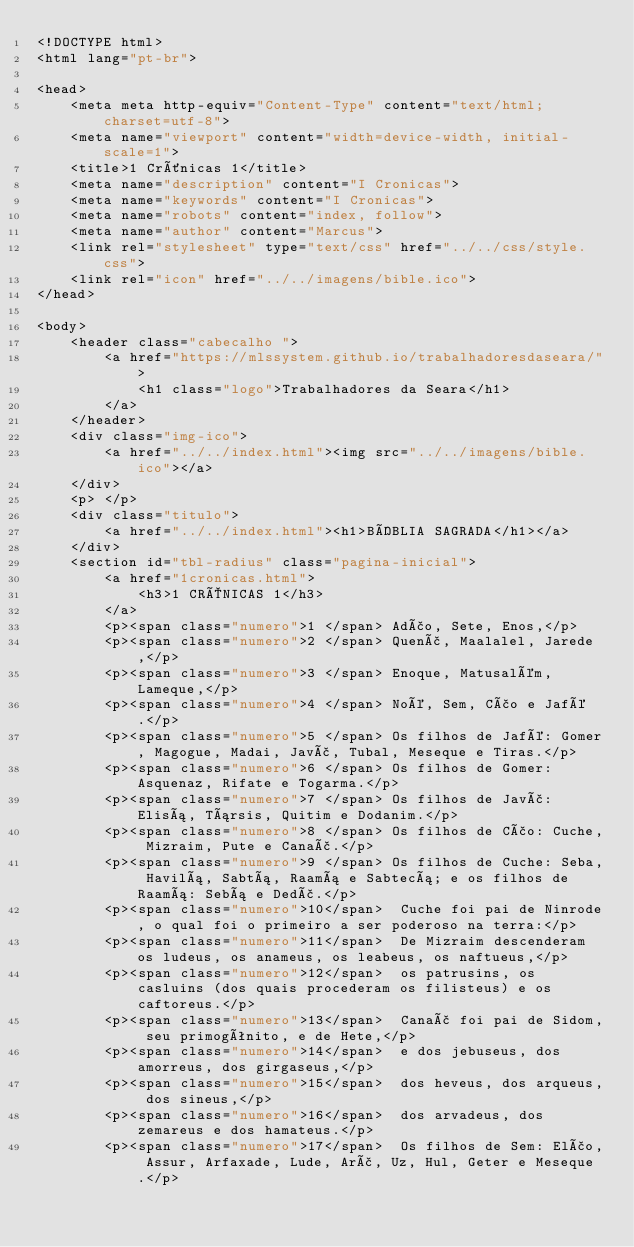Convert code to text. <code><loc_0><loc_0><loc_500><loc_500><_HTML_><!DOCTYPE html>
<html lang="pt-br">

<head>
    <meta meta http-equiv="Content-Type" content="text/html; charset=utf-8">
    <meta name="viewport" content="width=device-width, initial-scale=1">
    <title>1 Crônicas 1</title>
    <meta name="description" content="I Cronicas">
    <meta name="keywords" content="I Cronicas">
    <meta name="robots" content="index, follow">
    <meta name="author" content="Marcus">
    <link rel="stylesheet" type="text/css" href="../../css/style.css">
    <link rel="icon" href="../../imagens/bible.ico">
</head>

<body>
    <header class="cabecalho ">
        <a href="https://mlssystem.github.io/trabalhadoresdaseara/">
            <h1 class="logo">Trabalhadores da Seara</h1>
        </a>
    </header>
    <div class="img-ico">
        <a href="../../index.html"><img src="../../imagens/bible.ico"></a>
    </div>
    <p> </p> 
    <div class="titulo">
        <a href="../../index.html"><h1>BÍBLIA SAGRADA</h1></a>
    </div>
    <section id="tbl-radius" class="pagina-inicial">
        <a href="1cronicas.html">
            <h3>1 CRÔNICAS 1</h3>
        </a>
        <p><span class="numero">1 </span> Adão, Sete, Enos,</p>
        <p><span class="numero">2 </span> Quenã, Maalalel, Jarede,</p>
        <p><span class="numero">3 </span> Enoque, Matusalém, Lameque,</p>
        <p><span class="numero">4 </span> Noé, Sem, Cão e Jafé.</p>
        <p><span class="numero">5 </span> Os filhos de Jafé: Gomer, Magogue, Madai, Javã, Tubal, Meseque e Tiras.</p>
        <p><span class="numero">6 </span> Os filhos de Gomer: Asquenaz, Rifate e Togarma.</p>
        <p><span class="numero">7 </span> Os filhos de Javã: Elisá, Társis, Quitim e Dodanim.</p>
        <p><span class="numero">8 </span> Os filhos de Cão: Cuche, Mizraim, Pute e Canaã.</p>
        <p><span class="numero">9 </span> Os filhos de Cuche: Seba, Havilá, Sabtá, Raamá e Sabtecá; e os filhos de Raamá: Sebá e Dedã.</p>
        <p><span class="numero">10</span>  Cuche foi pai de Ninrode, o qual foi o primeiro a ser poderoso na terra:</p>
        <p><span class="numero">11</span>  De Mizraim descenderam os ludeus, os anameus, os leabeus, os naftueus,</p>
        <p><span class="numero">12</span>  os patrusins, os casluins (dos quais procederam os filisteus) e os caftoreus.</p>
        <p><span class="numero">13</span>  Canaã foi pai de Sidom, seu primogênito, e de Hete,</p>
        <p><span class="numero">14</span>  e dos jebuseus, dos amorreus, dos girgaseus,</p>
        <p><span class="numero">15</span>  dos heveus, dos arqueus, dos sineus,</p>
        <p><span class="numero">16</span>  dos arvadeus, dos zemareus e dos hamateus.</p>
        <p><span class="numero">17</span>  Os filhos de Sem: Elão, Assur, Arfaxade, Lude, Arã, Uz, Hul, Geter e Meseque.</p></code> 